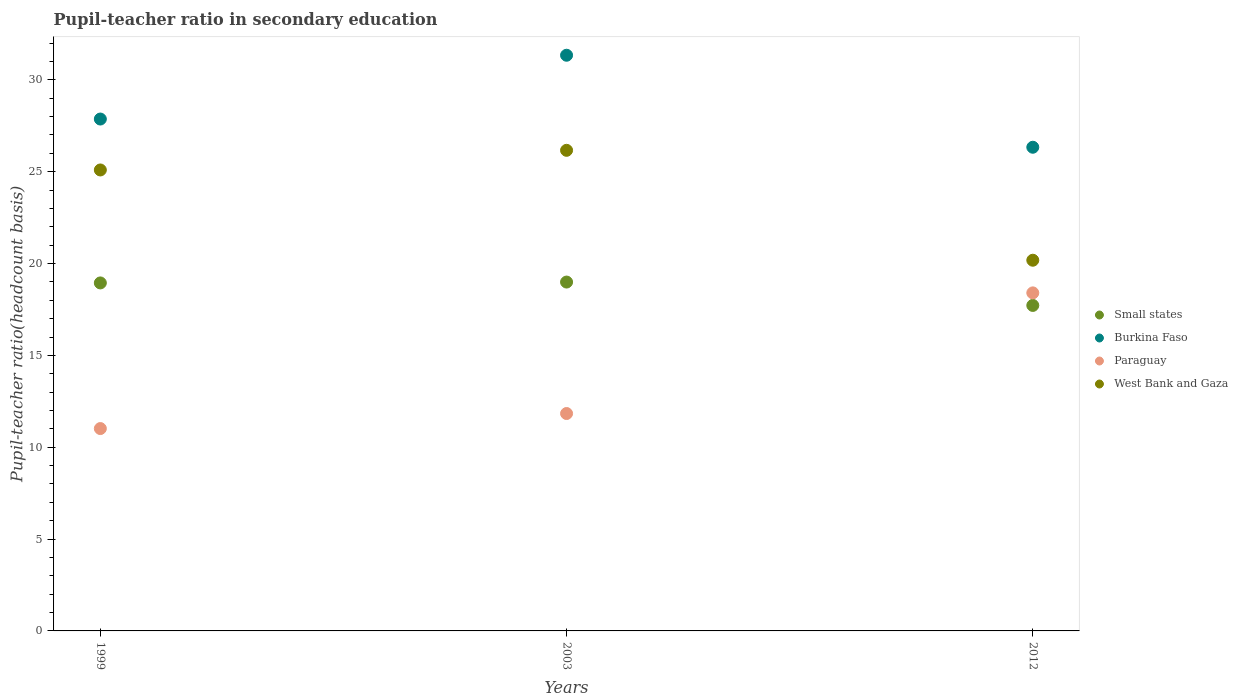How many different coloured dotlines are there?
Give a very brief answer. 4. Is the number of dotlines equal to the number of legend labels?
Provide a short and direct response. Yes. What is the pupil-teacher ratio in secondary education in Paraguay in 2003?
Make the answer very short. 11.84. Across all years, what is the maximum pupil-teacher ratio in secondary education in West Bank and Gaza?
Make the answer very short. 26.17. Across all years, what is the minimum pupil-teacher ratio in secondary education in West Bank and Gaza?
Your answer should be compact. 20.18. In which year was the pupil-teacher ratio in secondary education in Paraguay minimum?
Offer a very short reply. 1999. What is the total pupil-teacher ratio in secondary education in Burkina Faso in the graph?
Ensure brevity in your answer.  85.54. What is the difference between the pupil-teacher ratio in secondary education in Small states in 2003 and that in 2012?
Make the answer very short. 1.27. What is the difference between the pupil-teacher ratio in secondary education in Small states in 2003 and the pupil-teacher ratio in secondary education in Burkina Faso in 2012?
Make the answer very short. -7.34. What is the average pupil-teacher ratio in secondary education in Paraguay per year?
Give a very brief answer. 13.75. In the year 2012, what is the difference between the pupil-teacher ratio in secondary education in Burkina Faso and pupil-teacher ratio in secondary education in Paraguay?
Ensure brevity in your answer.  7.93. In how many years, is the pupil-teacher ratio in secondary education in Paraguay greater than 14?
Your answer should be very brief. 1. What is the ratio of the pupil-teacher ratio in secondary education in Burkina Faso in 1999 to that in 2012?
Provide a succinct answer. 1.06. Is the difference between the pupil-teacher ratio in secondary education in Burkina Faso in 1999 and 2003 greater than the difference between the pupil-teacher ratio in secondary education in Paraguay in 1999 and 2003?
Offer a very short reply. No. What is the difference between the highest and the second highest pupil-teacher ratio in secondary education in West Bank and Gaza?
Make the answer very short. 1.07. What is the difference between the highest and the lowest pupil-teacher ratio in secondary education in Small states?
Provide a succinct answer. 1.27. Is the sum of the pupil-teacher ratio in secondary education in Burkina Faso in 1999 and 2012 greater than the maximum pupil-teacher ratio in secondary education in West Bank and Gaza across all years?
Provide a short and direct response. Yes. Is it the case that in every year, the sum of the pupil-teacher ratio in secondary education in West Bank and Gaza and pupil-teacher ratio in secondary education in Small states  is greater than the sum of pupil-teacher ratio in secondary education in Burkina Faso and pupil-teacher ratio in secondary education in Paraguay?
Keep it short and to the point. Yes. Does the pupil-teacher ratio in secondary education in West Bank and Gaza monotonically increase over the years?
Offer a terse response. No. Is the pupil-teacher ratio in secondary education in Burkina Faso strictly greater than the pupil-teacher ratio in secondary education in West Bank and Gaza over the years?
Your answer should be compact. Yes. Are the values on the major ticks of Y-axis written in scientific E-notation?
Your answer should be compact. No. Does the graph contain grids?
Provide a succinct answer. No. Where does the legend appear in the graph?
Provide a succinct answer. Center right. What is the title of the graph?
Your answer should be compact. Pupil-teacher ratio in secondary education. What is the label or title of the Y-axis?
Keep it short and to the point. Pupil-teacher ratio(headcount basis). What is the Pupil-teacher ratio(headcount basis) of Small states in 1999?
Provide a succinct answer. 18.95. What is the Pupil-teacher ratio(headcount basis) of Burkina Faso in 1999?
Provide a short and direct response. 27.87. What is the Pupil-teacher ratio(headcount basis) in Paraguay in 1999?
Your response must be concise. 11.02. What is the Pupil-teacher ratio(headcount basis) in West Bank and Gaza in 1999?
Ensure brevity in your answer.  25.1. What is the Pupil-teacher ratio(headcount basis) of Small states in 2003?
Keep it short and to the point. 18.99. What is the Pupil-teacher ratio(headcount basis) of Burkina Faso in 2003?
Your answer should be compact. 31.34. What is the Pupil-teacher ratio(headcount basis) in Paraguay in 2003?
Provide a succinct answer. 11.84. What is the Pupil-teacher ratio(headcount basis) of West Bank and Gaza in 2003?
Give a very brief answer. 26.17. What is the Pupil-teacher ratio(headcount basis) in Small states in 2012?
Provide a short and direct response. 17.72. What is the Pupil-teacher ratio(headcount basis) of Burkina Faso in 2012?
Your answer should be very brief. 26.33. What is the Pupil-teacher ratio(headcount basis) of Paraguay in 2012?
Your answer should be compact. 18.4. What is the Pupil-teacher ratio(headcount basis) of West Bank and Gaza in 2012?
Give a very brief answer. 20.18. Across all years, what is the maximum Pupil-teacher ratio(headcount basis) in Small states?
Offer a very short reply. 18.99. Across all years, what is the maximum Pupil-teacher ratio(headcount basis) of Burkina Faso?
Make the answer very short. 31.34. Across all years, what is the maximum Pupil-teacher ratio(headcount basis) of Paraguay?
Make the answer very short. 18.4. Across all years, what is the maximum Pupil-teacher ratio(headcount basis) of West Bank and Gaza?
Offer a very short reply. 26.17. Across all years, what is the minimum Pupil-teacher ratio(headcount basis) in Small states?
Ensure brevity in your answer.  17.72. Across all years, what is the minimum Pupil-teacher ratio(headcount basis) in Burkina Faso?
Provide a succinct answer. 26.33. Across all years, what is the minimum Pupil-teacher ratio(headcount basis) of Paraguay?
Offer a very short reply. 11.02. Across all years, what is the minimum Pupil-teacher ratio(headcount basis) of West Bank and Gaza?
Provide a short and direct response. 20.18. What is the total Pupil-teacher ratio(headcount basis) in Small states in the graph?
Give a very brief answer. 55.66. What is the total Pupil-teacher ratio(headcount basis) of Burkina Faso in the graph?
Your answer should be compact. 85.54. What is the total Pupil-teacher ratio(headcount basis) of Paraguay in the graph?
Your answer should be very brief. 41.26. What is the total Pupil-teacher ratio(headcount basis) in West Bank and Gaza in the graph?
Your response must be concise. 71.44. What is the difference between the Pupil-teacher ratio(headcount basis) of Small states in 1999 and that in 2003?
Provide a succinct answer. -0.05. What is the difference between the Pupil-teacher ratio(headcount basis) of Burkina Faso in 1999 and that in 2003?
Give a very brief answer. -3.47. What is the difference between the Pupil-teacher ratio(headcount basis) of Paraguay in 1999 and that in 2003?
Provide a short and direct response. -0.82. What is the difference between the Pupil-teacher ratio(headcount basis) in West Bank and Gaza in 1999 and that in 2003?
Offer a very short reply. -1.07. What is the difference between the Pupil-teacher ratio(headcount basis) of Small states in 1999 and that in 2012?
Keep it short and to the point. 1.23. What is the difference between the Pupil-teacher ratio(headcount basis) of Burkina Faso in 1999 and that in 2012?
Make the answer very short. 1.54. What is the difference between the Pupil-teacher ratio(headcount basis) of Paraguay in 1999 and that in 2012?
Provide a succinct answer. -7.39. What is the difference between the Pupil-teacher ratio(headcount basis) of West Bank and Gaza in 1999 and that in 2012?
Offer a very short reply. 4.91. What is the difference between the Pupil-teacher ratio(headcount basis) of Small states in 2003 and that in 2012?
Your answer should be compact. 1.27. What is the difference between the Pupil-teacher ratio(headcount basis) of Burkina Faso in 2003 and that in 2012?
Offer a terse response. 5.01. What is the difference between the Pupil-teacher ratio(headcount basis) of Paraguay in 2003 and that in 2012?
Your answer should be very brief. -6.57. What is the difference between the Pupil-teacher ratio(headcount basis) of West Bank and Gaza in 2003 and that in 2012?
Provide a short and direct response. 5.98. What is the difference between the Pupil-teacher ratio(headcount basis) of Small states in 1999 and the Pupil-teacher ratio(headcount basis) of Burkina Faso in 2003?
Offer a very short reply. -12.4. What is the difference between the Pupil-teacher ratio(headcount basis) of Small states in 1999 and the Pupil-teacher ratio(headcount basis) of Paraguay in 2003?
Your answer should be compact. 7.11. What is the difference between the Pupil-teacher ratio(headcount basis) in Small states in 1999 and the Pupil-teacher ratio(headcount basis) in West Bank and Gaza in 2003?
Your answer should be very brief. -7.22. What is the difference between the Pupil-teacher ratio(headcount basis) in Burkina Faso in 1999 and the Pupil-teacher ratio(headcount basis) in Paraguay in 2003?
Give a very brief answer. 16.03. What is the difference between the Pupil-teacher ratio(headcount basis) of Burkina Faso in 1999 and the Pupil-teacher ratio(headcount basis) of West Bank and Gaza in 2003?
Offer a very short reply. 1.7. What is the difference between the Pupil-teacher ratio(headcount basis) of Paraguay in 1999 and the Pupil-teacher ratio(headcount basis) of West Bank and Gaza in 2003?
Provide a succinct answer. -15.15. What is the difference between the Pupil-teacher ratio(headcount basis) in Small states in 1999 and the Pupil-teacher ratio(headcount basis) in Burkina Faso in 2012?
Offer a very short reply. -7.39. What is the difference between the Pupil-teacher ratio(headcount basis) of Small states in 1999 and the Pupil-teacher ratio(headcount basis) of Paraguay in 2012?
Provide a short and direct response. 0.54. What is the difference between the Pupil-teacher ratio(headcount basis) in Small states in 1999 and the Pupil-teacher ratio(headcount basis) in West Bank and Gaza in 2012?
Make the answer very short. -1.24. What is the difference between the Pupil-teacher ratio(headcount basis) in Burkina Faso in 1999 and the Pupil-teacher ratio(headcount basis) in Paraguay in 2012?
Offer a very short reply. 9.46. What is the difference between the Pupil-teacher ratio(headcount basis) in Burkina Faso in 1999 and the Pupil-teacher ratio(headcount basis) in West Bank and Gaza in 2012?
Provide a short and direct response. 7.69. What is the difference between the Pupil-teacher ratio(headcount basis) of Paraguay in 1999 and the Pupil-teacher ratio(headcount basis) of West Bank and Gaza in 2012?
Ensure brevity in your answer.  -9.16. What is the difference between the Pupil-teacher ratio(headcount basis) in Small states in 2003 and the Pupil-teacher ratio(headcount basis) in Burkina Faso in 2012?
Your answer should be compact. -7.34. What is the difference between the Pupil-teacher ratio(headcount basis) of Small states in 2003 and the Pupil-teacher ratio(headcount basis) of Paraguay in 2012?
Give a very brief answer. 0.59. What is the difference between the Pupil-teacher ratio(headcount basis) of Small states in 2003 and the Pupil-teacher ratio(headcount basis) of West Bank and Gaza in 2012?
Provide a succinct answer. -1.19. What is the difference between the Pupil-teacher ratio(headcount basis) in Burkina Faso in 2003 and the Pupil-teacher ratio(headcount basis) in Paraguay in 2012?
Ensure brevity in your answer.  12.94. What is the difference between the Pupil-teacher ratio(headcount basis) of Burkina Faso in 2003 and the Pupil-teacher ratio(headcount basis) of West Bank and Gaza in 2012?
Keep it short and to the point. 11.16. What is the difference between the Pupil-teacher ratio(headcount basis) of Paraguay in 2003 and the Pupil-teacher ratio(headcount basis) of West Bank and Gaza in 2012?
Your response must be concise. -8.35. What is the average Pupil-teacher ratio(headcount basis) in Small states per year?
Your answer should be very brief. 18.55. What is the average Pupil-teacher ratio(headcount basis) in Burkina Faso per year?
Offer a terse response. 28.51. What is the average Pupil-teacher ratio(headcount basis) in Paraguay per year?
Make the answer very short. 13.75. What is the average Pupil-teacher ratio(headcount basis) of West Bank and Gaza per year?
Your response must be concise. 23.81. In the year 1999, what is the difference between the Pupil-teacher ratio(headcount basis) of Small states and Pupil-teacher ratio(headcount basis) of Burkina Faso?
Offer a very short reply. -8.92. In the year 1999, what is the difference between the Pupil-teacher ratio(headcount basis) of Small states and Pupil-teacher ratio(headcount basis) of Paraguay?
Give a very brief answer. 7.93. In the year 1999, what is the difference between the Pupil-teacher ratio(headcount basis) in Small states and Pupil-teacher ratio(headcount basis) in West Bank and Gaza?
Ensure brevity in your answer.  -6.15. In the year 1999, what is the difference between the Pupil-teacher ratio(headcount basis) of Burkina Faso and Pupil-teacher ratio(headcount basis) of Paraguay?
Make the answer very short. 16.85. In the year 1999, what is the difference between the Pupil-teacher ratio(headcount basis) of Burkina Faso and Pupil-teacher ratio(headcount basis) of West Bank and Gaza?
Ensure brevity in your answer.  2.77. In the year 1999, what is the difference between the Pupil-teacher ratio(headcount basis) in Paraguay and Pupil-teacher ratio(headcount basis) in West Bank and Gaza?
Ensure brevity in your answer.  -14.08. In the year 2003, what is the difference between the Pupil-teacher ratio(headcount basis) of Small states and Pupil-teacher ratio(headcount basis) of Burkina Faso?
Keep it short and to the point. -12.35. In the year 2003, what is the difference between the Pupil-teacher ratio(headcount basis) in Small states and Pupil-teacher ratio(headcount basis) in Paraguay?
Make the answer very short. 7.16. In the year 2003, what is the difference between the Pupil-teacher ratio(headcount basis) in Small states and Pupil-teacher ratio(headcount basis) in West Bank and Gaza?
Offer a very short reply. -7.17. In the year 2003, what is the difference between the Pupil-teacher ratio(headcount basis) of Burkina Faso and Pupil-teacher ratio(headcount basis) of Paraguay?
Provide a succinct answer. 19.51. In the year 2003, what is the difference between the Pupil-teacher ratio(headcount basis) of Burkina Faso and Pupil-teacher ratio(headcount basis) of West Bank and Gaza?
Give a very brief answer. 5.18. In the year 2003, what is the difference between the Pupil-teacher ratio(headcount basis) in Paraguay and Pupil-teacher ratio(headcount basis) in West Bank and Gaza?
Your answer should be very brief. -14.33. In the year 2012, what is the difference between the Pupil-teacher ratio(headcount basis) in Small states and Pupil-teacher ratio(headcount basis) in Burkina Faso?
Offer a terse response. -8.61. In the year 2012, what is the difference between the Pupil-teacher ratio(headcount basis) in Small states and Pupil-teacher ratio(headcount basis) in Paraguay?
Your answer should be very brief. -0.68. In the year 2012, what is the difference between the Pupil-teacher ratio(headcount basis) of Small states and Pupil-teacher ratio(headcount basis) of West Bank and Gaza?
Offer a very short reply. -2.46. In the year 2012, what is the difference between the Pupil-teacher ratio(headcount basis) in Burkina Faso and Pupil-teacher ratio(headcount basis) in Paraguay?
Your answer should be very brief. 7.93. In the year 2012, what is the difference between the Pupil-teacher ratio(headcount basis) in Burkina Faso and Pupil-teacher ratio(headcount basis) in West Bank and Gaza?
Provide a short and direct response. 6.15. In the year 2012, what is the difference between the Pupil-teacher ratio(headcount basis) of Paraguay and Pupil-teacher ratio(headcount basis) of West Bank and Gaza?
Make the answer very short. -1.78. What is the ratio of the Pupil-teacher ratio(headcount basis) of Burkina Faso in 1999 to that in 2003?
Your answer should be very brief. 0.89. What is the ratio of the Pupil-teacher ratio(headcount basis) of Paraguay in 1999 to that in 2003?
Provide a succinct answer. 0.93. What is the ratio of the Pupil-teacher ratio(headcount basis) of West Bank and Gaza in 1999 to that in 2003?
Your response must be concise. 0.96. What is the ratio of the Pupil-teacher ratio(headcount basis) in Small states in 1999 to that in 2012?
Offer a terse response. 1.07. What is the ratio of the Pupil-teacher ratio(headcount basis) of Burkina Faso in 1999 to that in 2012?
Make the answer very short. 1.06. What is the ratio of the Pupil-teacher ratio(headcount basis) of Paraguay in 1999 to that in 2012?
Keep it short and to the point. 0.6. What is the ratio of the Pupil-teacher ratio(headcount basis) in West Bank and Gaza in 1999 to that in 2012?
Keep it short and to the point. 1.24. What is the ratio of the Pupil-teacher ratio(headcount basis) in Small states in 2003 to that in 2012?
Ensure brevity in your answer.  1.07. What is the ratio of the Pupil-teacher ratio(headcount basis) of Burkina Faso in 2003 to that in 2012?
Keep it short and to the point. 1.19. What is the ratio of the Pupil-teacher ratio(headcount basis) of Paraguay in 2003 to that in 2012?
Provide a short and direct response. 0.64. What is the ratio of the Pupil-teacher ratio(headcount basis) in West Bank and Gaza in 2003 to that in 2012?
Keep it short and to the point. 1.3. What is the difference between the highest and the second highest Pupil-teacher ratio(headcount basis) of Small states?
Ensure brevity in your answer.  0.05. What is the difference between the highest and the second highest Pupil-teacher ratio(headcount basis) of Burkina Faso?
Offer a very short reply. 3.47. What is the difference between the highest and the second highest Pupil-teacher ratio(headcount basis) in Paraguay?
Keep it short and to the point. 6.57. What is the difference between the highest and the second highest Pupil-teacher ratio(headcount basis) of West Bank and Gaza?
Make the answer very short. 1.07. What is the difference between the highest and the lowest Pupil-teacher ratio(headcount basis) of Small states?
Provide a short and direct response. 1.27. What is the difference between the highest and the lowest Pupil-teacher ratio(headcount basis) in Burkina Faso?
Offer a terse response. 5.01. What is the difference between the highest and the lowest Pupil-teacher ratio(headcount basis) in Paraguay?
Offer a terse response. 7.39. What is the difference between the highest and the lowest Pupil-teacher ratio(headcount basis) of West Bank and Gaza?
Your response must be concise. 5.98. 